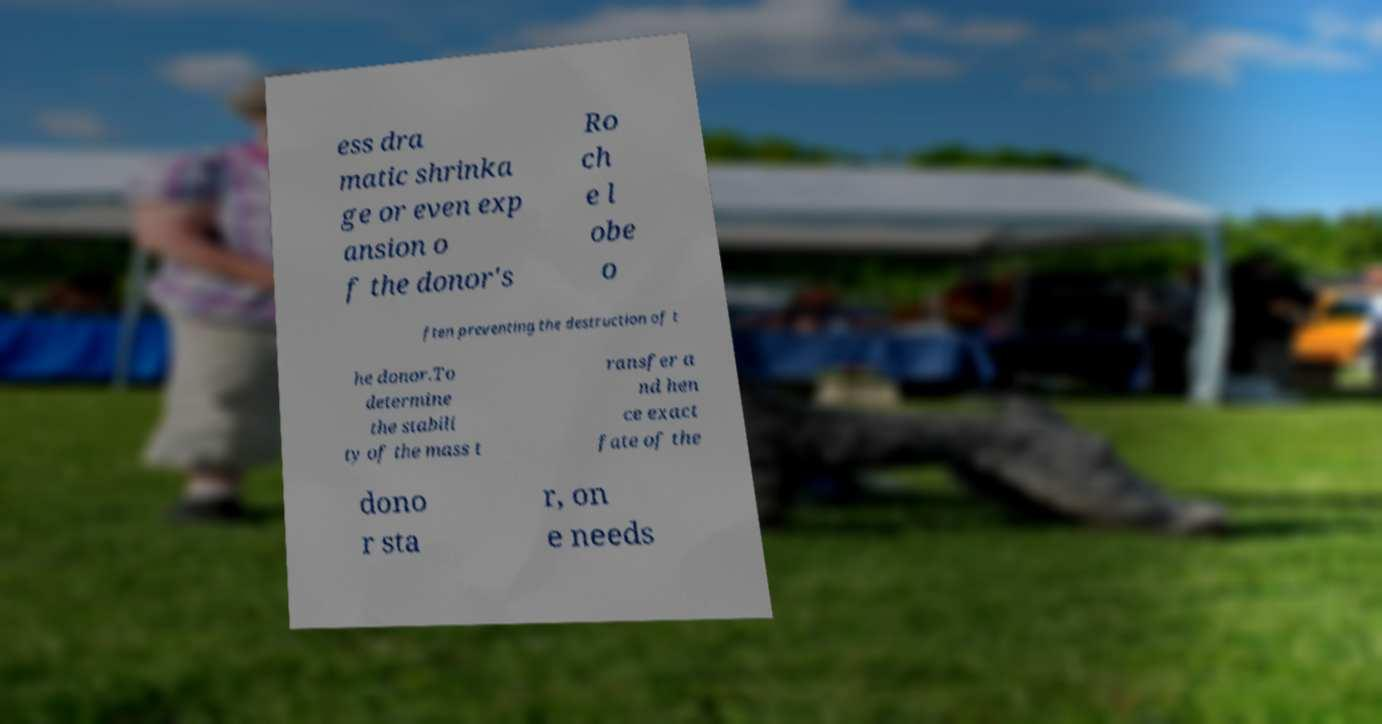Can you read and provide the text displayed in the image?This photo seems to have some interesting text. Can you extract and type it out for me? ess dra matic shrinka ge or even exp ansion o f the donor's Ro ch e l obe o ften preventing the destruction of t he donor.To determine the stabili ty of the mass t ransfer a nd hen ce exact fate of the dono r sta r, on e needs 